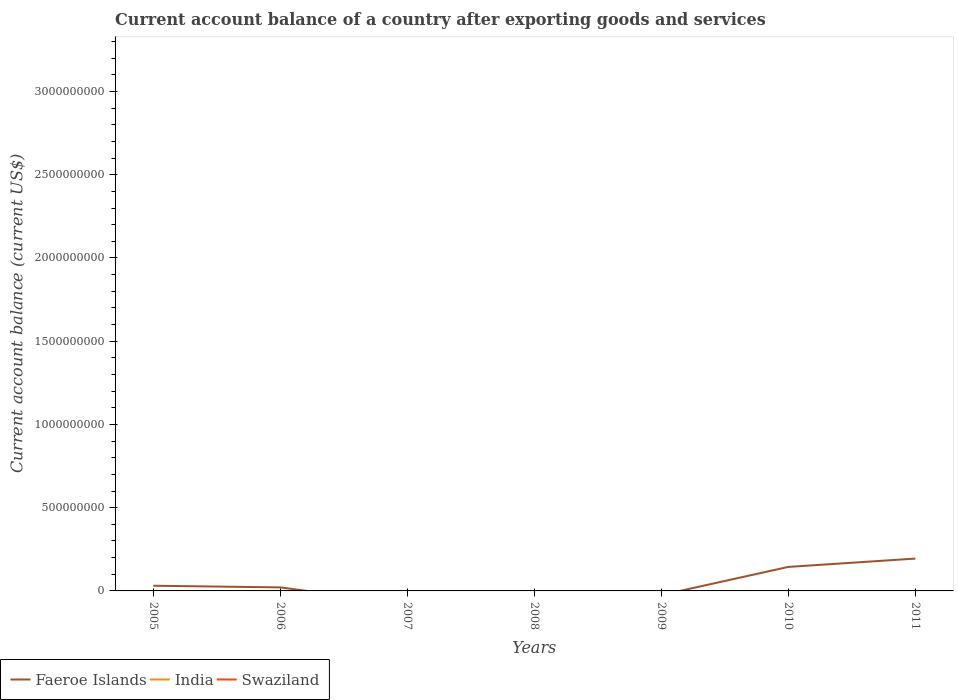What is the total account balance in Faeroe Islands in the graph?
Your response must be concise. -5.00e+07. What is the difference between the highest and the second highest account balance in Faeroe Islands?
Make the answer very short. 1.94e+08. What is the difference between the highest and the lowest account balance in Faeroe Islands?
Your response must be concise. 2. Is the account balance in Swaziland strictly greater than the account balance in Faeroe Islands over the years?
Your response must be concise. No. Are the values on the major ticks of Y-axis written in scientific E-notation?
Offer a terse response. No. Where does the legend appear in the graph?
Your response must be concise. Bottom left. What is the title of the graph?
Your response must be concise. Current account balance of a country after exporting goods and services. Does "Jamaica" appear as one of the legend labels in the graph?
Your answer should be very brief. No. What is the label or title of the Y-axis?
Your answer should be compact. Current account balance (current US$). What is the Current account balance (current US$) of Faeroe Islands in 2005?
Provide a short and direct response. 3.12e+07. What is the Current account balance (current US$) of Faeroe Islands in 2006?
Your answer should be compact. 2.12e+07. What is the Current account balance (current US$) in India in 2006?
Offer a very short reply. 0. What is the Current account balance (current US$) in Swaziland in 2006?
Offer a very short reply. 0. What is the Current account balance (current US$) in Faeroe Islands in 2007?
Your answer should be very brief. 0. What is the Current account balance (current US$) in India in 2007?
Offer a terse response. 0. What is the Current account balance (current US$) of India in 2008?
Your answer should be compact. 0. What is the Current account balance (current US$) of Swaziland in 2008?
Give a very brief answer. 0. What is the Current account balance (current US$) in Swaziland in 2009?
Make the answer very short. 0. What is the Current account balance (current US$) in Faeroe Islands in 2010?
Provide a short and direct response. 1.44e+08. What is the Current account balance (current US$) of Swaziland in 2010?
Your answer should be compact. 0. What is the Current account balance (current US$) of Faeroe Islands in 2011?
Your answer should be compact. 1.94e+08. What is the Current account balance (current US$) of Swaziland in 2011?
Your answer should be very brief. 0. Across all years, what is the maximum Current account balance (current US$) of Faeroe Islands?
Keep it short and to the point. 1.94e+08. What is the total Current account balance (current US$) in Faeroe Islands in the graph?
Your response must be concise. 3.91e+08. What is the total Current account balance (current US$) in India in the graph?
Make the answer very short. 0. What is the total Current account balance (current US$) of Swaziland in the graph?
Offer a very short reply. 0. What is the difference between the Current account balance (current US$) in Faeroe Islands in 2005 and that in 2006?
Offer a very short reply. 9.94e+06. What is the difference between the Current account balance (current US$) of Faeroe Islands in 2005 and that in 2010?
Offer a terse response. -1.13e+08. What is the difference between the Current account balance (current US$) in Faeroe Islands in 2005 and that in 2011?
Your answer should be very brief. -1.63e+08. What is the difference between the Current account balance (current US$) of Faeroe Islands in 2006 and that in 2010?
Offer a terse response. -1.23e+08. What is the difference between the Current account balance (current US$) of Faeroe Islands in 2006 and that in 2011?
Offer a terse response. -1.73e+08. What is the difference between the Current account balance (current US$) of Faeroe Islands in 2010 and that in 2011?
Make the answer very short. -5.00e+07. What is the average Current account balance (current US$) of Faeroe Islands per year?
Make the answer very short. 5.59e+07. What is the average Current account balance (current US$) in Swaziland per year?
Offer a terse response. 0. What is the ratio of the Current account balance (current US$) of Faeroe Islands in 2005 to that in 2006?
Keep it short and to the point. 1.47. What is the ratio of the Current account balance (current US$) in Faeroe Islands in 2005 to that in 2010?
Provide a short and direct response. 0.22. What is the ratio of the Current account balance (current US$) in Faeroe Islands in 2005 to that in 2011?
Ensure brevity in your answer.  0.16. What is the ratio of the Current account balance (current US$) of Faeroe Islands in 2006 to that in 2010?
Offer a terse response. 0.15. What is the ratio of the Current account balance (current US$) of Faeroe Islands in 2006 to that in 2011?
Your answer should be very brief. 0.11. What is the ratio of the Current account balance (current US$) in Faeroe Islands in 2010 to that in 2011?
Provide a succinct answer. 0.74. What is the difference between the highest and the second highest Current account balance (current US$) in Faeroe Islands?
Your answer should be compact. 5.00e+07. What is the difference between the highest and the lowest Current account balance (current US$) of Faeroe Islands?
Make the answer very short. 1.94e+08. 